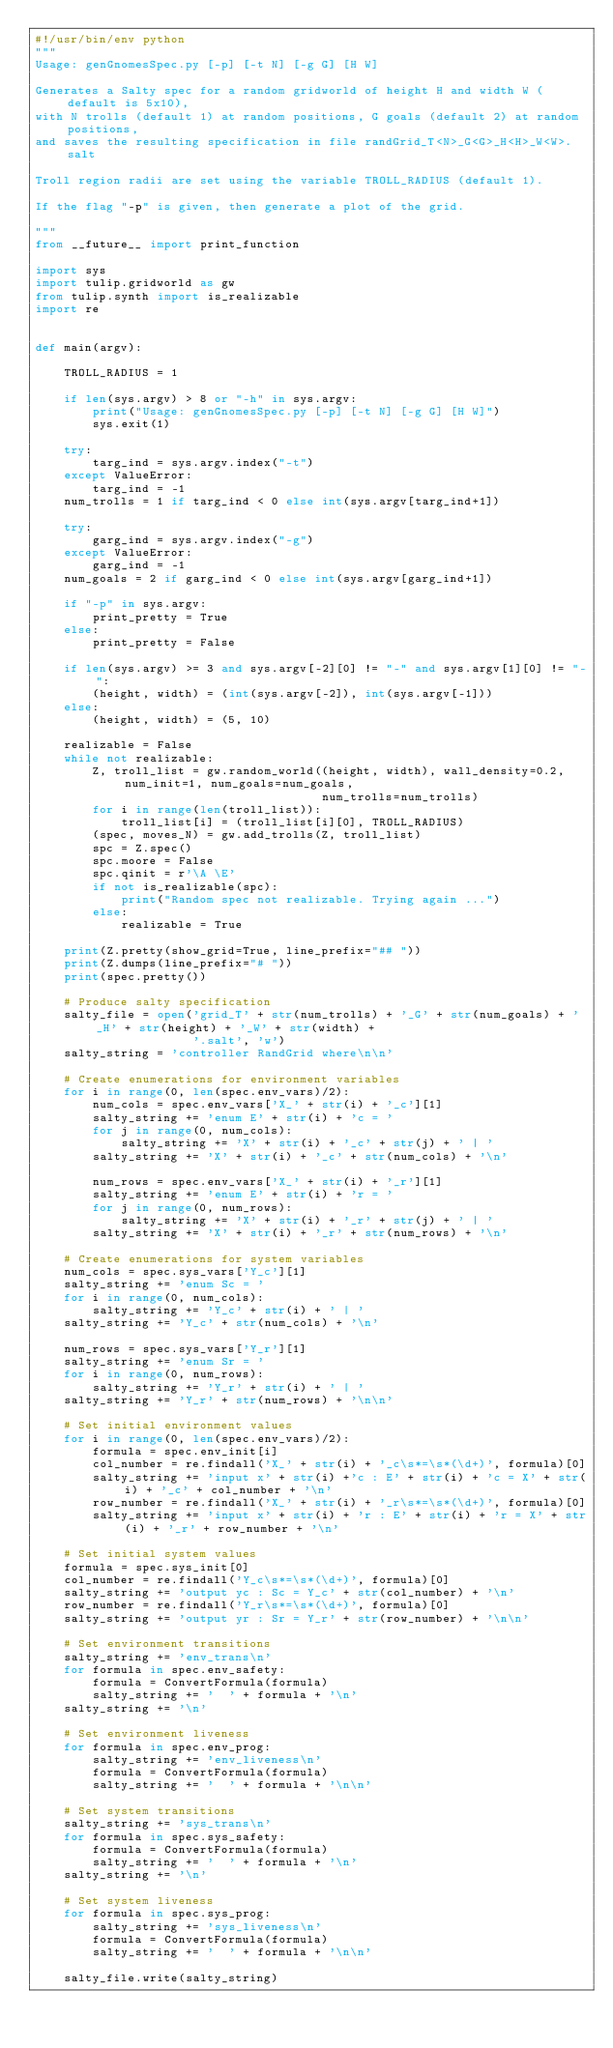Convert code to text. <code><loc_0><loc_0><loc_500><loc_500><_Python_>#!/usr/bin/env python
"""
Usage: genGnomesSpec.py [-p] [-t N] [-g G] [H W]

Generates a Salty spec for a random gridworld of height H and width W (default is 5x10),
with N trolls (default 1) at random positions, G goals (default 2) at random positions,
and saves the resulting specification in file randGrid_T<N>_G<G>_H<H>_W<W>.salt

Troll region radii are set using the variable TROLL_RADIUS (default 1).

If the flag "-p" is given, then generate a plot of the grid.

"""
from __future__ import print_function

import sys
import tulip.gridworld as gw
from tulip.synth import is_realizable
import re


def main(argv):

    TROLL_RADIUS = 1

    if len(sys.argv) > 8 or "-h" in sys.argv:
        print("Usage: genGnomesSpec.py [-p] [-t N] [-g G] [H W]")
        sys.exit(1)

    try:
        targ_ind = sys.argv.index("-t")
    except ValueError:
        targ_ind = -1
    num_trolls = 1 if targ_ind < 0 else int(sys.argv[targ_ind+1])

    try:
        garg_ind = sys.argv.index("-g")
    except ValueError:
        garg_ind = -1
    num_goals = 2 if garg_ind < 0 else int(sys.argv[garg_ind+1])

    if "-p" in sys.argv:
        print_pretty = True
    else:
        print_pretty = False

    if len(sys.argv) >= 3 and sys.argv[-2][0] != "-" and sys.argv[1][0] != "-":
        (height, width) = (int(sys.argv[-2]), int(sys.argv[-1]))
    else:
        (height, width) = (5, 10)

    realizable = False
    while not realizable:
        Z, troll_list = gw.random_world((height, width), wall_density=0.2, num_init=1, num_goals=num_goals,
                                        num_trolls=num_trolls)
        for i in range(len(troll_list)):
            troll_list[i] = (troll_list[i][0], TROLL_RADIUS)
        (spec, moves_N) = gw.add_trolls(Z, troll_list)
        spc = Z.spec()
        spc.moore = False
        spc.qinit = r'\A \E'
        if not is_realizable(spc):
            print("Random spec not realizable. Trying again ...")
        else:
            realizable = True

    print(Z.pretty(show_grid=True, line_prefix="## "))
    print(Z.dumps(line_prefix="# "))
    print(spec.pretty())

    # Produce salty specification
    salty_file = open('grid_T' + str(num_trolls) + '_G' + str(num_goals) + '_H' + str(height) + '_W' + str(width) +
                      '.salt', 'w')
    salty_string = 'controller RandGrid where\n\n'

    # Create enumerations for environment variables
    for i in range(0, len(spec.env_vars)/2):
        num_cols = spec.env_vars['X_' + str(i) + '_c'][1]
        salty_string += 'enum E' + str(i) + 'c = '
        for j in range(0, num_cols):
            salty_string += 'X' + str(i) + '_c' + str(j) + ' | '
        salty_string += 'X' + str(i) + '_c' + str(num_cols) + '\n'

        num_rows = spec.env_vars['X_' + str(i) + '_r'][1]
        salty_string += 'enum E' + str(i) + 'r = '
        for j in range(0, num_rows):
            salty_string += 'X' + str(i) + '_r' + str(j) + ' | '
        salty_string += 'X' + str(i) + '_r' + str(num_rows) + '\n'

    # Create enumerations for system variables
    num_cols = spec.sys_vars['Y_c'][1]
    salty_string += 'enum Sc = '
    for i in range(0, num_cols):
        salty_string += 'Y_c' + str(i) + ' | '
    salty_string += 'Y_c' + str(num_cols) + '\n'

    num_rows = spec.sys_vars['Y_r'][1]
    salty_string += 'enum Sr = '
    for i in range(0, num_rows):
        salty_string += 'Y_r' + str(i) + ' | '
    salty_string += 'Y_r' + str(num_rows) + '\n\n'

    # Set initial environment values
    for i in range(0, len(spec.env_vars)/2):
        formula = spec.env_init[i]
        col_number = re.findall('X_' + str(i) + '_c\s*=\s*(\d+)', formula)[0]
        salty_string += 'input x' + str(i) +'c : E' + str(i) + 'c = X' + str(i) + '_c' + col_number + '\n'
        row_number = re.findall('X_' + str(i) + '_r\s*=\s*(\d+)', formula)[0]
        salty_string += 'input x' + str(i) + 'r : E' + str(i) + 'r = X' + str(i) + '_r' + row_number + '\n'

    # Set initial system values
    formula = spec.sys_init[0]
    col_number = re.findall('Y_c\s*=\s*(\d+)', formula)[0]
    salty_string += 'output yc : Sc = Y_c' + str(col_number) + '\n'
    row_number = re.findall('Y_r\s*=\s*(\d+)', formula)[0]
    salty_string += 'output yr : Sr = Y_r' + str(row_number) + '\n\n'

    # Set environment transitions
    salty_string += 'env_trans\n'
    for formula in spec.env_safety:
        formula = ConvertFormula(formula)
        salty_string += '  ' + formula + '\n'
    salty_string += '\n'

    # Set environment liveness
    for formula in spec.env_prog:
        salty_string += 'env_liveness\n'
        formula = ConvertFormula(formula)
        salty_string += '  ' + formula + '\n\n'

    # Set system transitions
    salty_string += 'sys_trans\n'
    for formula in spec.sys_safety:
        formula = ConvertFormula(formula)
        salty_string += '  ' + formula + '\n'
    salty_string += '\n'

    # Set system liveness
    for formula in spec.sys_prog:
        salty_string += 'sys_liveness\n'
        formula = ConvertFormula(formula)
        salty_string += '  ' + formula + '\n\n'

    salty_file.write(salty_string)
</code> 